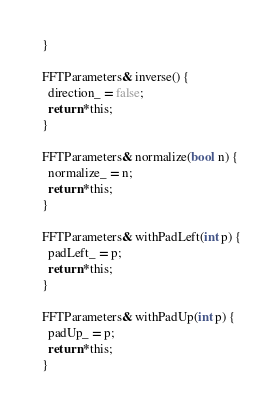Convert code to text. <code><loc_0><loc_0><loc_500><loc_500><_Cuda_>  }

  FFTParameters& inverse() {
    direction_ = false;
    return *this;
  }

  FFTParameters& normalize(bool n) {
    normalize_ = n;
    return *this;
  }

  FFTParameters& withPadLeft(int p) {
    padLeft_ = p;
    return *this;
  }

  FFTParameters& withPadUp(int p) {
    padUp_ = p;
    return *this;
  }
</code> 